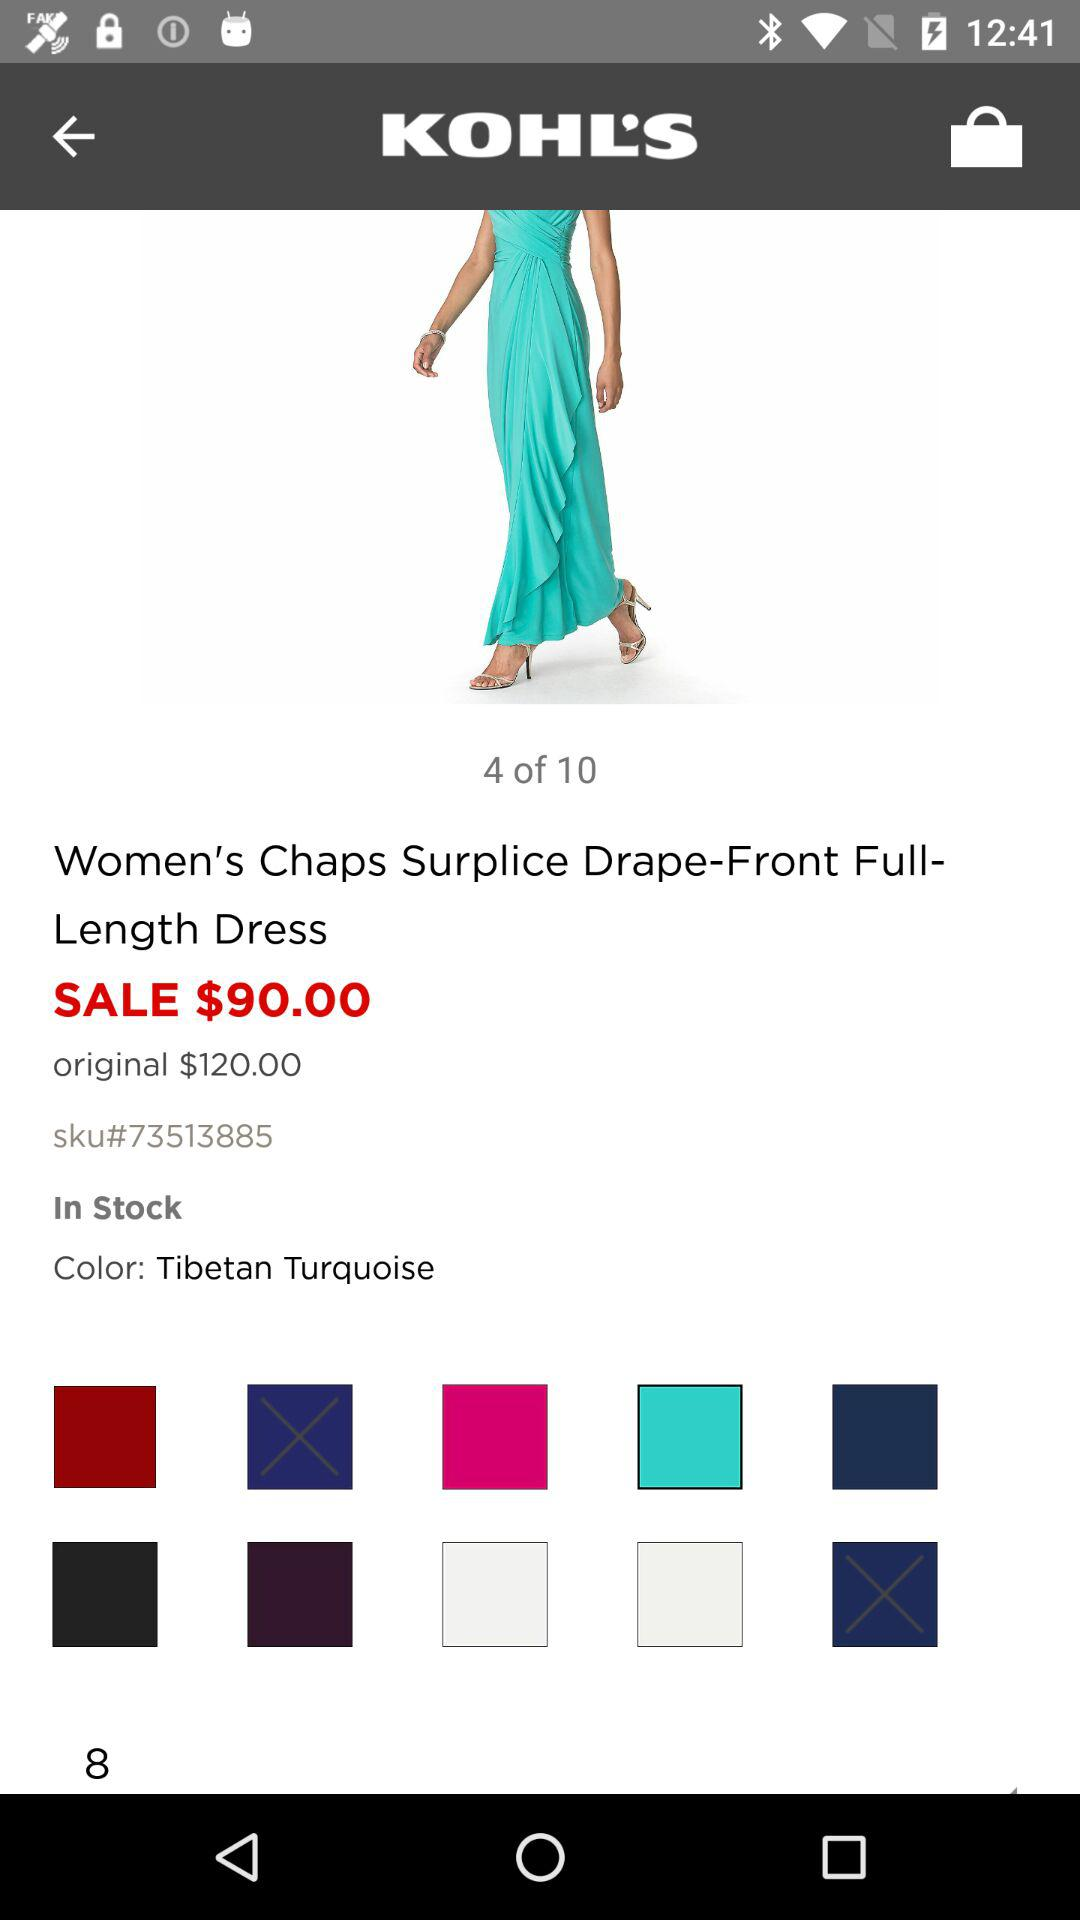What is the name of the dress? The name of the dress is "Women's Chaps Surplice Drape-Front Full-Length Dress". 